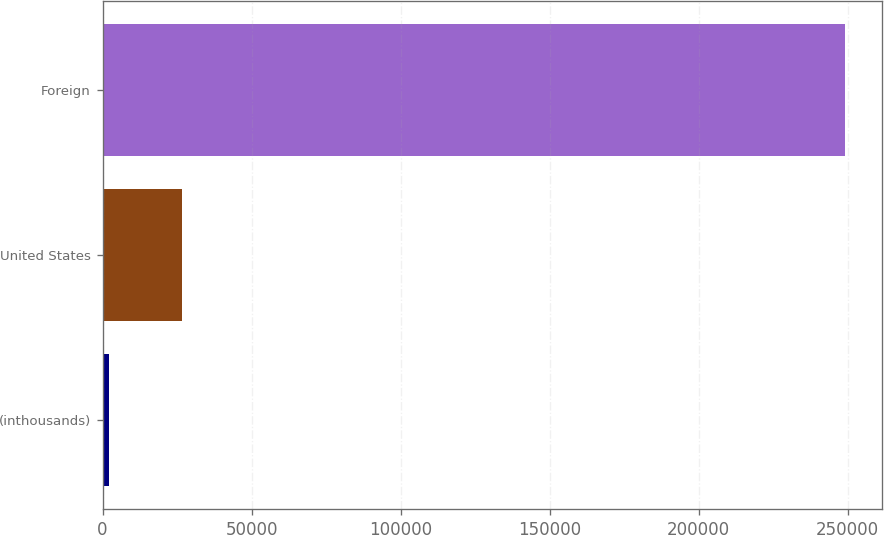Convert chart to OTSL. <chart><loc_0><loc_0><loc_500><loc_500><bar_chart><fcel>(inthousands)<fcel>United States<fcel>Foreign<nl><fcel>2011<fcel>26716.9<fcel>249070<nl></chart> 